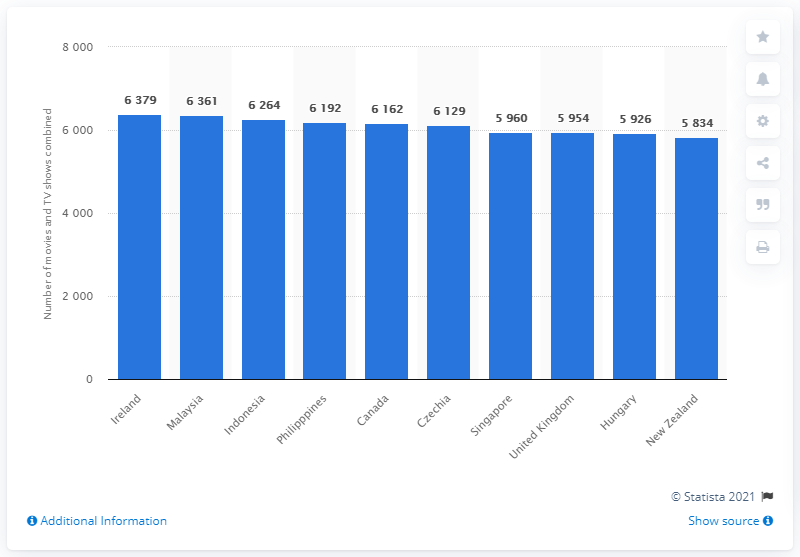Point out several critical features in this image. The second largest Netflix library in the world is Malaysia. 